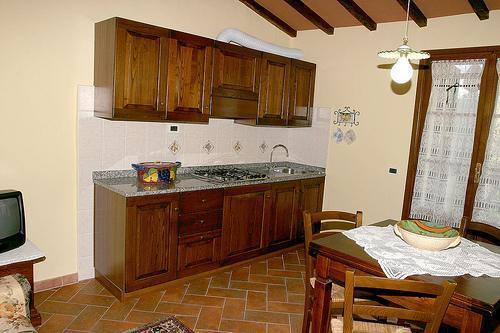How many chairs are there?
Give a very brief answer. 3. 